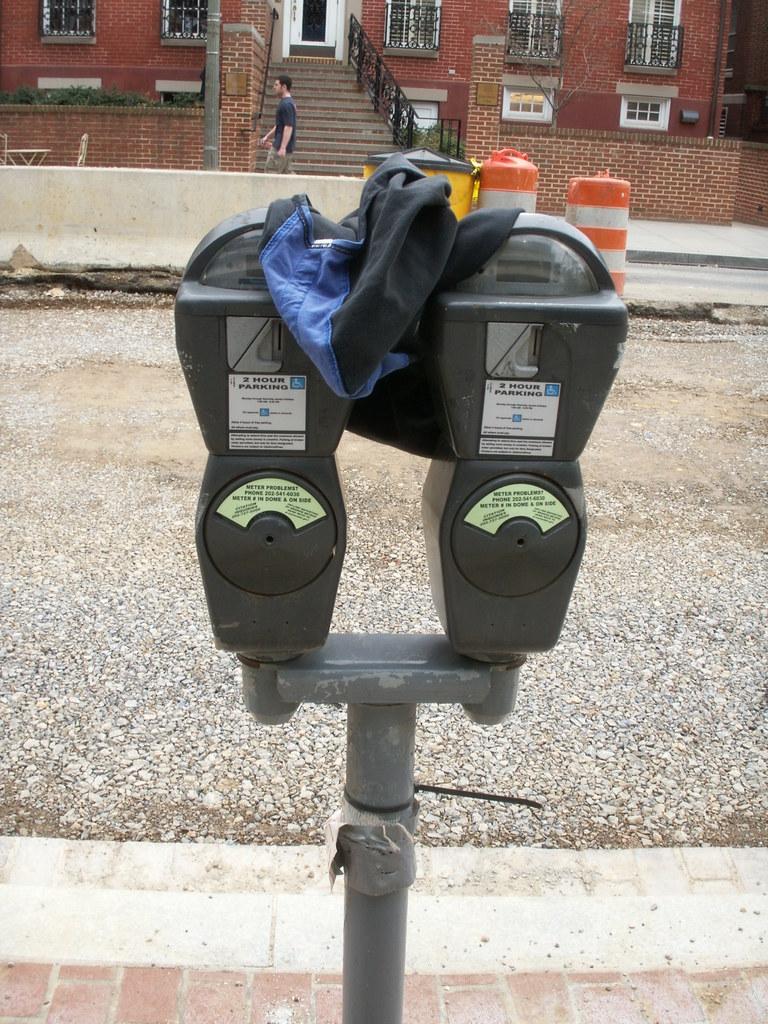How many hours parking does the meter allow?
Keep it short and to the point. 2. 